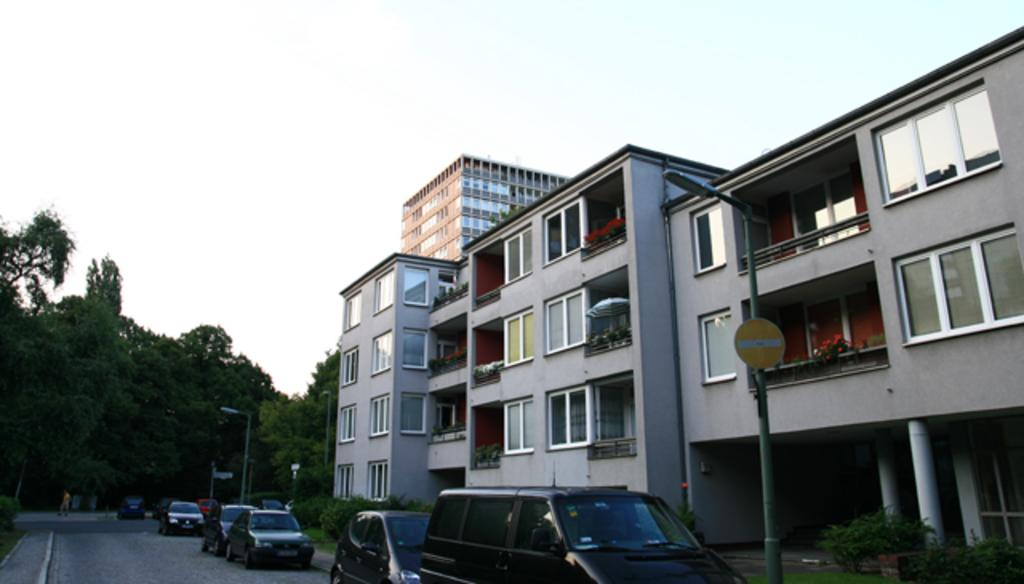What type of structure is visible in the image? There is a building in the image. What can be seen on the road in front of the building? Vehicles are parked on the road in front of the building. What is visible at the top of the image? The sky is visible at the top of the image. What type of vegetation is on the left side of the image? There are trees on the left side of the image. What type of knowledge can be gained from the land in the image? There is no specific knowledge mentioned or implied in the image, as it primarily features a building, parked vehicles, the sky, and trees. 